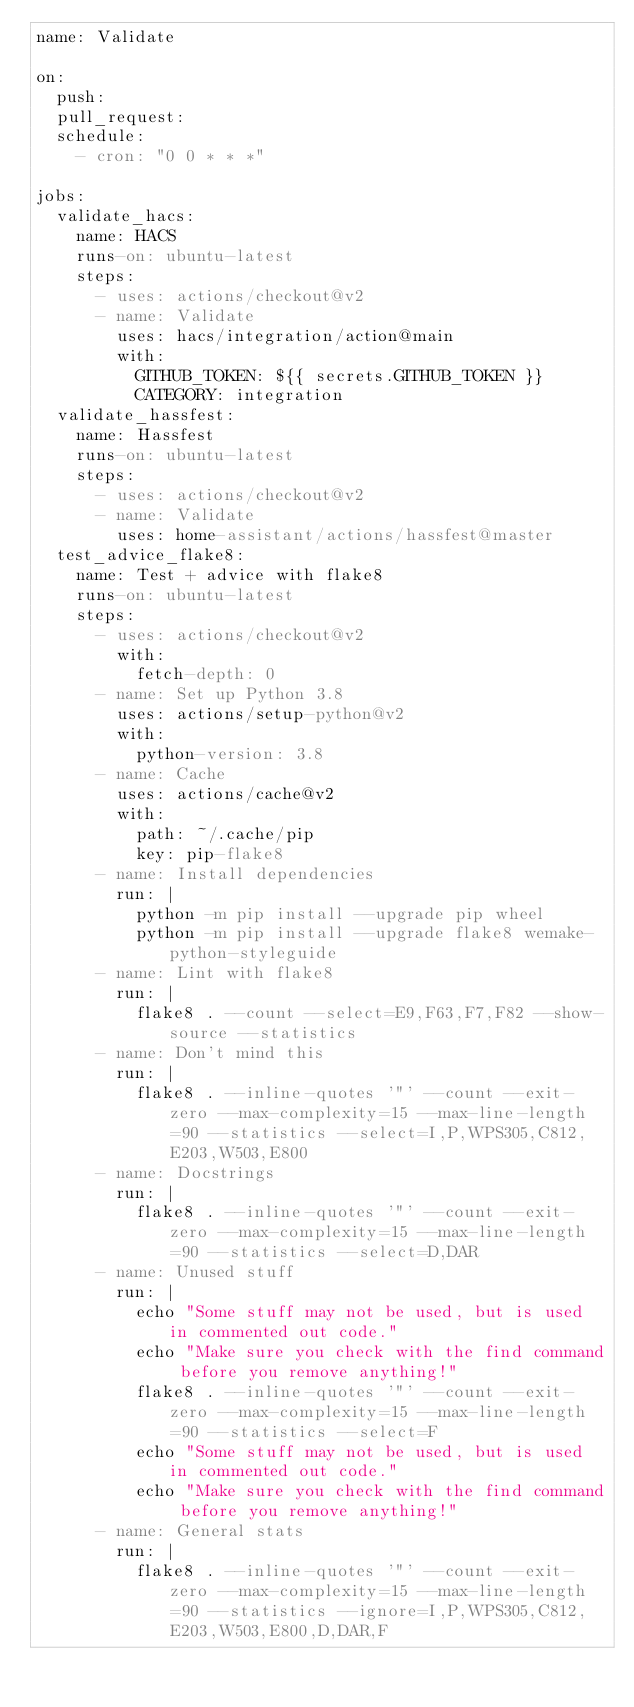Convert code to text. <code><loc_0><loc_0><loc_500><loc_500><_YAML_>name: Validate

on:
  push:
  pull_request:
  schedule:
    - cron: "0 0 * * *"

jobs:
  validate_hacs:
    name: HACS
    runs-on: ubuntu-latest
    steps:
      - uses: actions/checkout@v2
      - name: Validate
        uses: hacs/integration/action@main
        with:
          GITHUB_TOKEN: ${{ secrets.GITHUB_TOKEN }}
          CATEGORY: integration
  validate_hassfest:
    name: Hassfest
    runs-on: ubuntu-latest
    steps:
      - uses: actions/checkout@v2
      - name: Validate
        uses: home-assistant/actions/hassfest@master
  test_advice_flake8:
    name: Test + advice with flake8
    runs-on: ubuntu-latest
    steps:
      - uses: actions/checkout@v2
        with:
          fetch-depth: 0
      - name: Set up Python 3.8
        uses: actions/setup-python@v2
        with:
          python-version: 3.8
      - name: Cache
        uses: actions/cache@v2
        with:
          path: ~/.cache/pip
          key: pip-flake8
      - name: Install dependencies
        run: |
          python -m pip install --upgrade pip wheel
          python -m pip install --upgrade flake8 wemake-python-styleguide
      - name: Lint with flake8
        run: |
          flake8 . --count --select=E9,F63,F7,F82 --show-source --statistics
      - name: Don't mind this
        run: |
          flake8 . --inline-quotes '"' --count --exit-zero --max-complexity=15 --max-line-length=90 --statistics --select=I,P,WPS305,C812,E203,W503,E800
      - name: Docstrings
        run: |
          flake8 . --inline-quotes '"' --count --exit-zero --max-complexity=15 --max-line-length=90 --statistics --select=D,DAR
      - name: Unused stuff
        run: |
          echo "Some stuff may not be used, but is used in commented out code."
          echo "Make sure you check with the find command before you remove anything!"
          flake8 . --inline-quotes '"' --count --exit-zero --max-complexity=15 --max-line-length=90 --statistics --select=F
          echo "Some stuff may not be used, but is used in commented out code."
          echo "Make sure you check with the find command before you remove anything!"
      - name: General stats
        run: |
          flake8 . --inline-quotes '"' --count --exit-zero --max-complexity=15 --max-line-length=90 --statistics --ignore=I,P,WPS305,C812,E203,W503,E800,D,DAR,F
</code> 